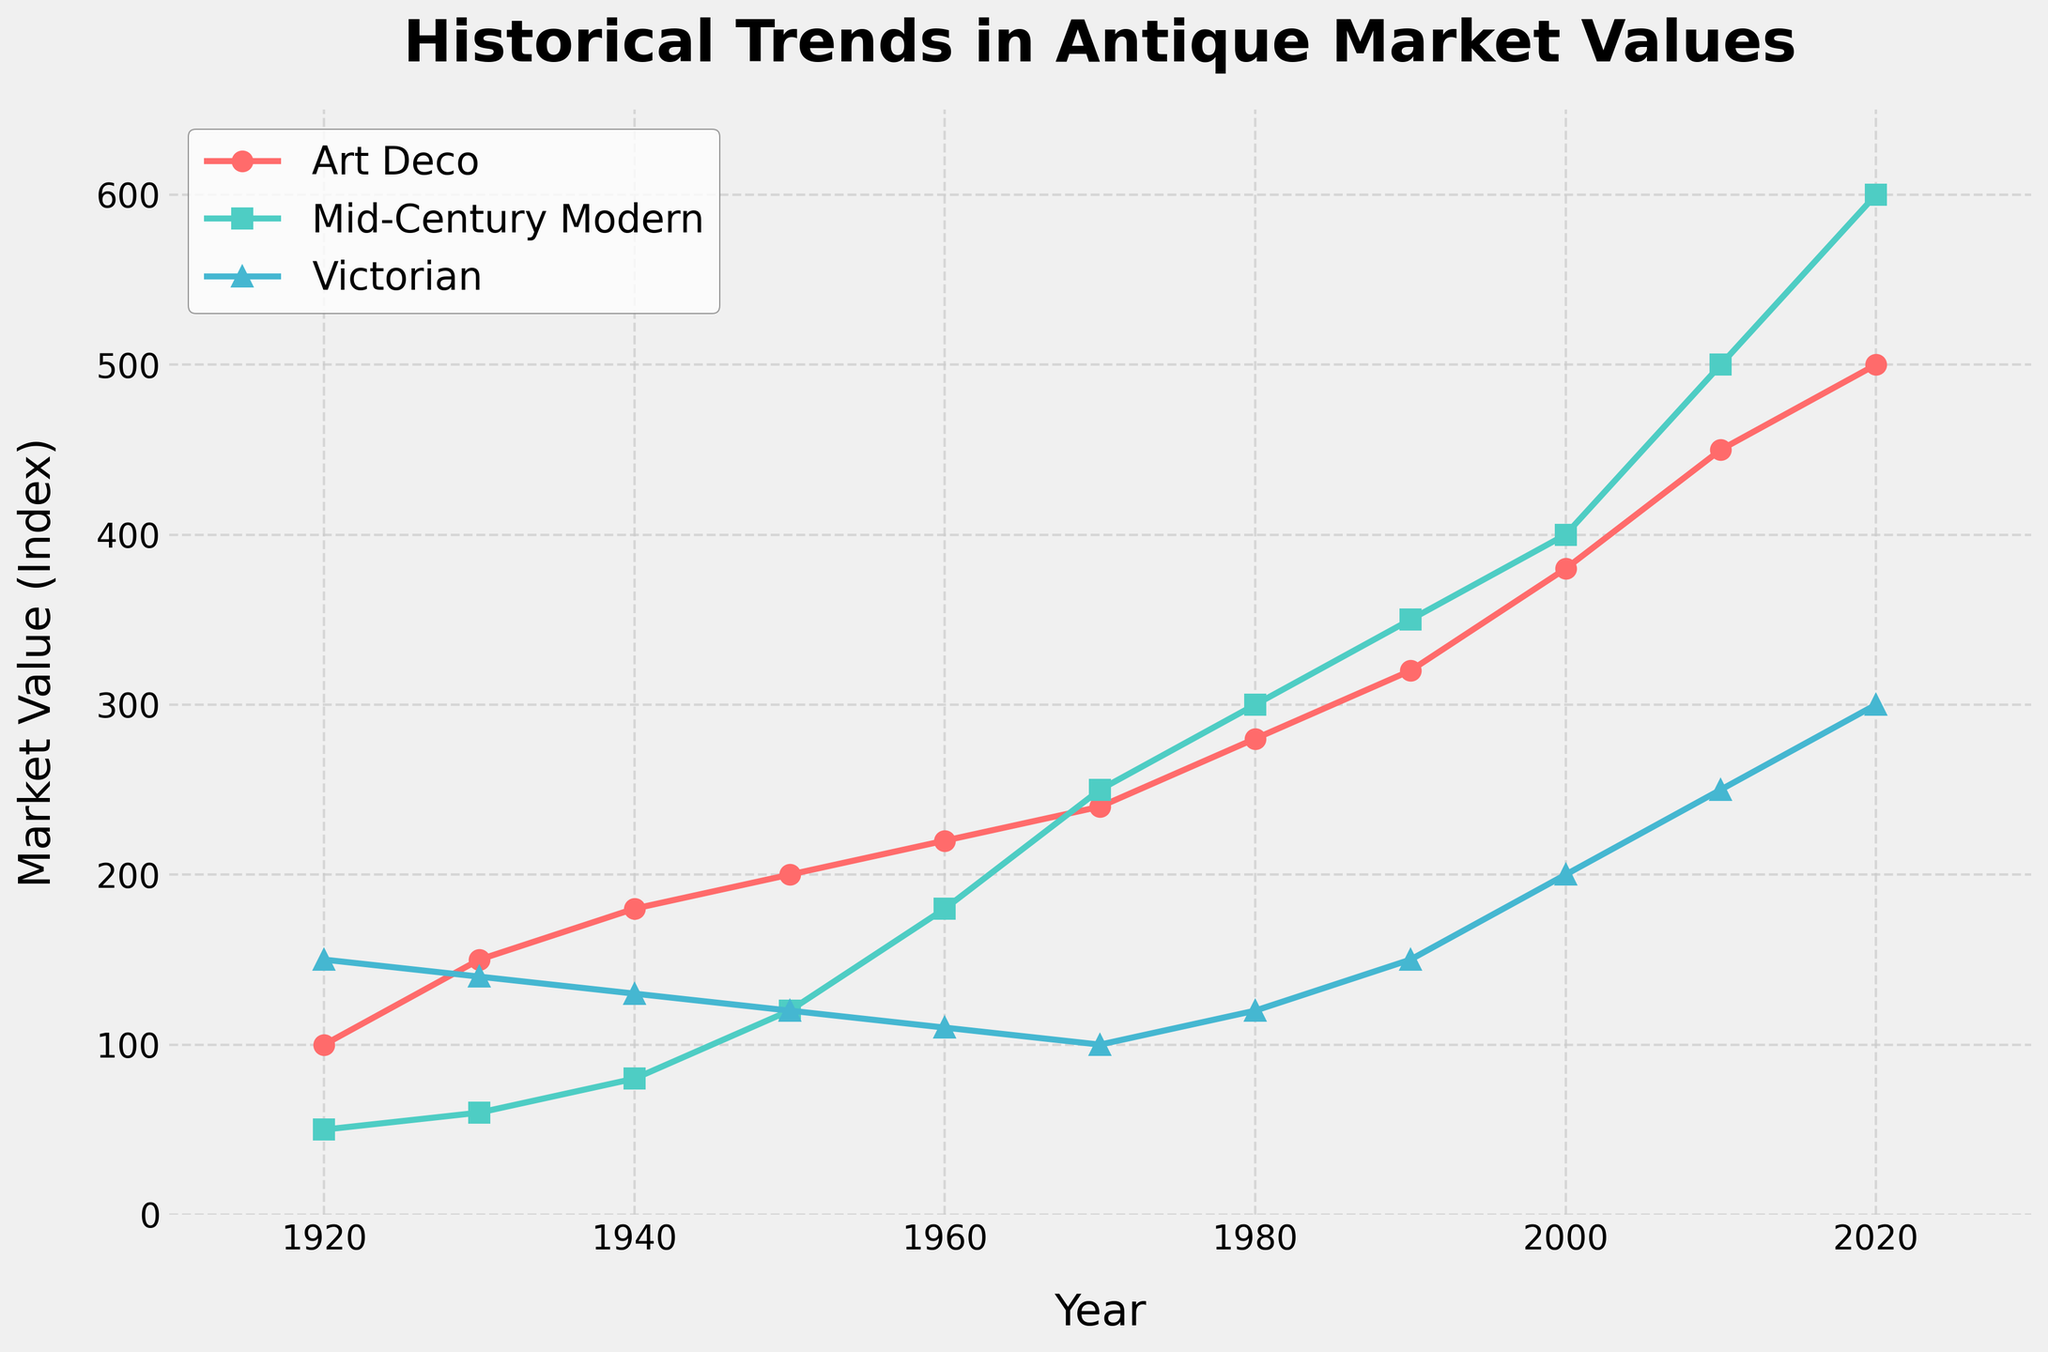What year did Mid-Century Modern values surpass those of Victorian? Begin by observing the values for both categories over time. Notice that in 1970, both values intersect at 100. After 1970, the value for Mid-Century Modern exceeds that of Victorian.
Answer: 1970 Which category had the highest market value in 2000? In 2000, compare the values of all three categories. Art Deco is at 380, Mid-Century Modern at 400, and Victorian at 200. The highest value is for Mid-Century Modern.
Answer: Mid-Century Modern In which decade did Art Deco values see the smallest increase? Observe the changes in each decade. From 1920-1930, the increase is 50; from 1930-1940, it is 30; from 1940-1950, it is 20; from 1950-1960, it is 20; from 1960-1970, it is 20; from 1970-1980, it is 40; from 1980-1990, it is 40; from 1990-2000, it is 60; from 2000-2010, it is 70; from 2010-2020, it is 50. The smallest increase is from 1940-1950.
Answer: 1940-1950 By how much has the value of Victorian antiques increased between 1920 and 2020? Subtract the value in 1920 from the value in 2020. Victorian value in 1920 is 150 and in 2020 is 300. 300 - 150 = 150.
Answer: 150 Which category had the steepest growth in market value, and in which period was this observed? Observe the trends and slopes. Mid-Century Modern shows the steepest growth, especially from 2010 to 2020, increasing by 100 units.
Answer: Mid-Century Modern, 2010-2020 